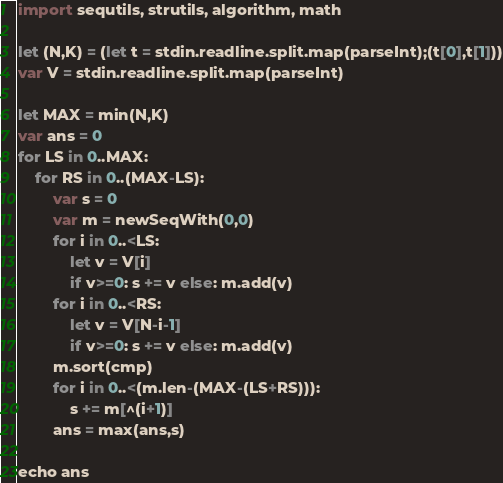Convert code to text. <code><loc_0><loc_0><loc_500><loc_500><_Nim_>import sequtils, strutils, algorithm, math

let (N,K) = (let t = stdin.readline.split.map(parseInt);(t[0],t[1]))
var V = stdin.readline.split.map(parseInt)

let MAX = min(N,K)
var ans = 0
for LS in 0..MAX:
    for RS in 0..(MAX-LS):
        var s = 0
        var m = newSeqWith(0,0)
        for i in 0..<LS:
            let v = V[i]
            if v>=0: s += v else: m.add(v)
        for i in 0..<RS:
            let v = V[N-i-1]
            if v>=0: s += v else: m.add(v)
        m.sort(cmp)
        for i in 0..<(m.len-(MAX-(LS+RS))):
            s += m[^(i+1)]
        ans = max(ans,s)

echo ans</code> 